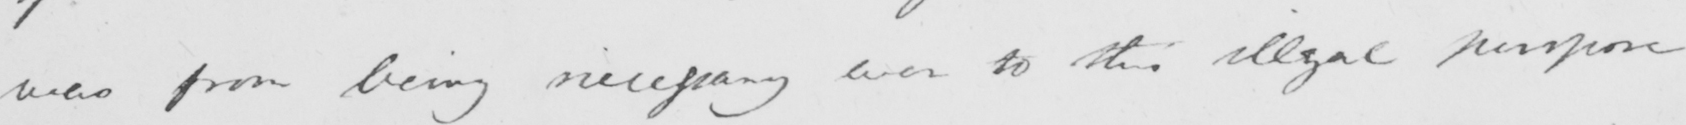What does this handwritten line say? was from being necessary even to this illegal purpose 